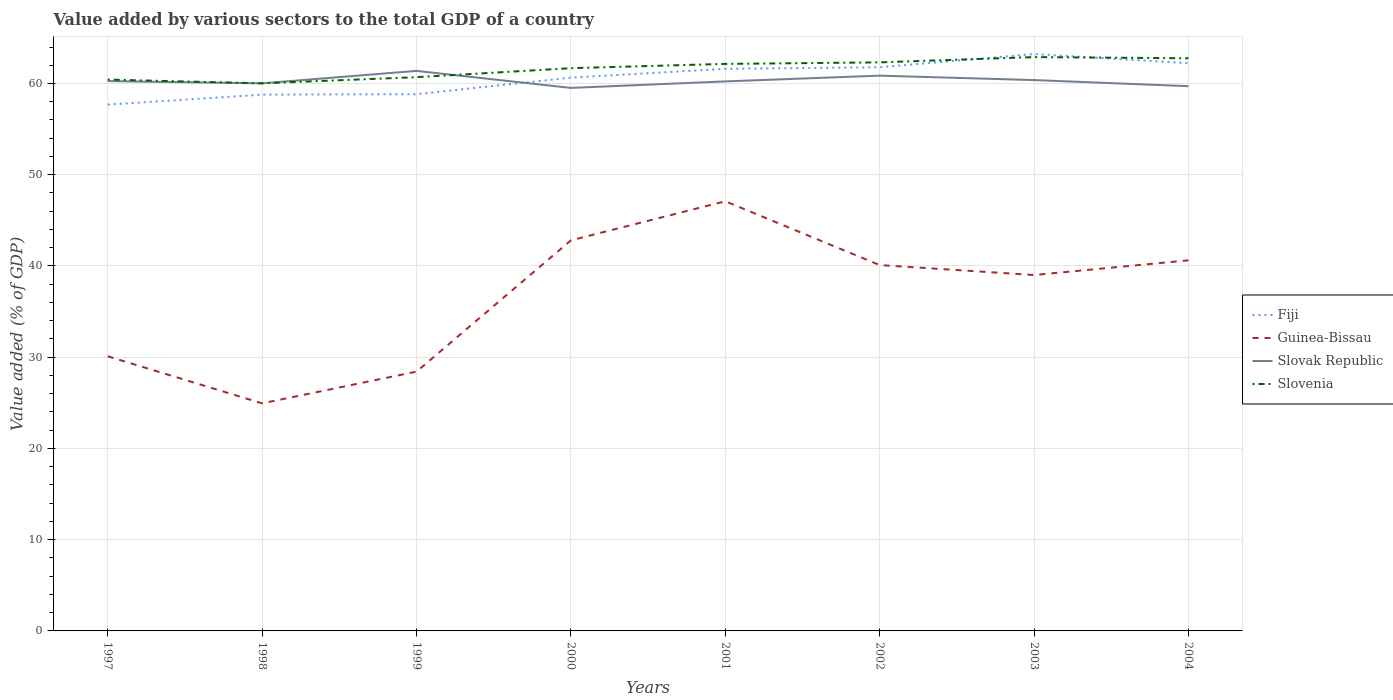Does the line corresponding to Guinea-Bissau intersect with the line corresponding to Slovenia?
Your answer should be very brief. No. Is the number of lines equal to the number of legend labels?
Offer a very short reply. Yes. Across all years, what is the maximum value added by various sectors to the total GDP in Guinea-Bissau?
Provide a succinct answer. 24.94. What is the total value added by various sectors to the total GDP in Fiji in the graph?
Give a very brief answer. -1.86. What is the difference between the highest and the second highest value added by various sectors to the total GDP in Slovak Republic?
Your answer should be very brief. 1.87. How many lines are there?
Your answer should be very brief. 4. How many years are there in the graph?
Keep it short and to the point. 8. Does the graph contain any zero values?
Provide a short and direct response. No. Does the graph contain grids?
Your answer should be compact. Yes. How many legend labels are there?
Give a very brief answer. 4. What is the title of the graph?
Your answer should be very brief. Value added by various sectors to the total GDP of a country. What is the label or title of the Y-axis?
Your answer should be very brief. Value added (% of GDP). What is the Value added (% of GDP) of Fiji in 1997?
Provide a succinct answer. 57.69. What is the Value added (% of GDP) of Guinea-Bissau in 1997?
Offer a terse response. 30.1. What is the Value added (% of GDP) of Slovak Republic in 1997?
Make the answer very short. 60.26. What is the Value added (% of GDP) of Slovenia in 1997?
Give a very brief answer. 60.43. What is the Value added (% of GDP) in Fiji in 1998?
Offer a terse response. 58.78. What is the Value added (% of GDP) in Guinea-Bissau in 1998?
Provide a succinct answer. 24.94. What is the Value added (% of GDP) of Slovak Republic in 1998?
Ensure brevity in your answer.  60.02. What is the Value added (% of GDP) of Slovenia in 1998?
Make the answer very short. 60.02. What is the Value added (% of GDP) of Fiji in 1999?
Offer a terse response. 58.83. What is the Value added (% of GDP) in Guinea-Bissau in 1999?
Offer a very short reply. 28.42. What is the Value added (% of GDP) of Slovak Republic in 1999?
Keep it short and to the point. 61.38. What is the Value added (% of GDP) of Slovenia in 1999?
Offer a very short reply. 60.69. What is the Value added (% of GDP) of Fiji in 2000?
Ensure brevity in your answer.  60.64. What is the Value added (% of GDP) of Guinea-Bissau in 2000?
Provide a succinct answer. 42.81. What is the Value added (% of GDP) in Slovak Republic in 2000?
Your answer should be very brief. 59.52. What is the Value added (% of GDP) in Slovenia in 2000?
Ensure brevity in your answer.  61.68. What is the Value added (% of GDP) of Fiji in 2001?
Your response must be concise. 61.61. What is the Value added (% of GDP) of Guinea-Bissau in 2001?
Provide a short and direct response. 47.09. What is the Value added (% of GDP) of Slovak Republic in 2001?
Offer a terse response. 60.23. What is the Value added (% of GDP) of Slovenia in 2001?
Offer a terse response. 62.15. What is the Value added (% of GDP) in Fiji in 2002?
Your response must be concise. 61.78. What is the Value added (% of GDP) in Guinea-Bissau in 2002?
Your response must be concise. 40.1. What is the Value added (% of GDP) of Slovak Republic in 2002?
Provide a succinct answer. 60.86. What is the Value added (% of GDP) in Slovenia in 2002?
Offer a terse response. 62.32. What is the Value added (% of GDP) in Fiji in 2003?
Your answer should be compact. 63.23. What is the Value added (% of GDP) of Guinea-Bissau in 2003?
Give a very brief answer. 39.01. What is the Value added (% of GDP) in Slovak Republic in 2003?
Your response must be concise. 60.37. What is the Value added (% of GDP) in Slovenia in 2003?
Your answer should be compact. 62.9. What is the Value added (% of GDP) of Fiji in 2004?
Offer a very short reply. 62.23. What is the Value added (% of GDP) in Guinea-Bissau in 2004?
Provide a succinct answer. 40.62. What is the Value added (% of GDP) of Slovak Republic in 2004?
Keep it short and to the point. 59.71. What is the Value added (% of GDP) in Slovenia in 2004?
Your answer should be very brief. 62.76. Across all years, what is the maximum Value added (% of GDP) of Fiji?
Your answer should be very brief. 63.23. Across all years, what is the maximum Value added (% of GDP) of Guinea-Bissau?
Your answer should be compact. 47.09. Across all years, what is the maximum Value added (% of GDP) of Slovak Republic?
Your response must be concise. 61.38. Across all years, what is the maximum Value added (% of GDP) in Slovenia?
Your answer should be very brief. 62.9. Across all years, what is the minimum Value added (% of GDP) of Fiji?
Your response must be concise. 57.69. Across all years, what is the minimum Value added (% of GDP) of Guinea-Bissau?
Keep it short and to the point. 24.94. Across all years, what is the minimum Value added (% of GDP) of Slovak Republic?
Give a very brief answer. 59.52. Across all years, what is the minimum Value added (% of GDP) in Slovenia?
Make the answer very short. 60.02. What is the total Value added (% of GDP) in Fiji in the graph?
Make the answer very short. 484.78. What is the total Value added (% of GDP) in Guinea-Bissau in the graph?
Give a very brief answer. 293.09. What is the total Value added (% of GDP) of Slovak Republic in the graph?
Offer a very short reply. 482.35. What is the total Value added (% of GDP) in Slovenia in the graph?
Make the answer very short. 492.94. What is the difference between the Value added (% of GDP) of Fiji in 1997 and that in 1998?
Offer a very short reply. -1.09. What is the difference between the Value added (% of GDP) in Guinea-Bissau in 1997 and that in 1998?
Offer a very short reply. 5.16. What is the difference between the Value added (% of GDP) in Slovak Republic in 1997 and that in 1998?
Make the answer very short. 0.25. What is the difference between the Value added (% of GDP) in Slovenia in 1997 and that in 1998?
Make the answer very short. 0.41. What is the difference between the Value added (% of GDP) of Fiji in 1997 and that in 1999?
Your response must be concise. -1.14. What is the difference between the Value added (% of GDP) of Guinea-Bissau in 1997 and that in 1999?
Your answer should be very brief. 1.68. What is the difference between the Value added (% of GDP) in Slovak Republic in 1997 and that in 1999?
Give a very brief answer. -1.12. What is the difference between the Value added (% of GDP) of Slovenia in 1997 and that in 1999?
Keep it short and to the point. -0.26. What is the difference between the Value added (% of GDP) of Fiji in 1997 and that in 2000?
Keep it short and to the point. -2.95. What is the difference between the Value added (% of GDP) in Guinea-Bissau in 1997 and that in 2000?
Provide a short and direct response. -12.71. What is the difference between the Value added (% of GDP) in Slovak Republic in 1997 and that in 2000?
Provide a short and direct response. 0.75. What is the difference between the Value added (% of GDP) of Slovenia in 1997 and that in 2000?
Give a very brief answer. -1.25. What is the difference between the Value added (% of GDP) in Fiji in 1997 and that in 2001?
Keep it short and to the point. -3.92. What is the difference between the Value added (% of GDP) of Guinea-Bissau in 1997 and that in 2001?
Your answer should be compact. -16.99. What is the difference between the Value added (% of GDP) of Slovak Republic in 1997 and that in 2001?
Make the answer very short. 0.03. What is the difference between the Value added (% of GDP) of Slovenia in 1997 and that in 2001?
Offer a very short reply. -1.72. What is the difference between the Value added (% of GDP) in Fiji in 1997 and that in 2002?
Ensure brevity in your answer.  -4.09. What is the difference between the Value added (% of GDP) in Guinea-Bissau in 1997 and that in 2002?
Provide a succinct answer. -10. What is the difference between the Value added (% of GDP) in Slovak Republic in 1997 and that in 2002?
Offer a very short reply. -0.6. What is the difference between the Value added (% of GDP) in Slovenia in 1997 and that in 2002?
Make the answer very short. -1.89. What is the difference between the Value added (% of GDP) in Fiji in 1997 and that in 2003?
Ensure brevity in your answer.  -5.54. What is the difference between the Value added (% of GDP) of Guinea-Bissau in 1997 and that in 2003?
Make the answer very short. -8.91. What is the difference between the Value added (% of GDP) in Slovak Republic in 1997 and that in 2003?
Ensure brevity in your answer.  -0.11. What is the difference between the Value added (% of GDP) in Slovenia in 1997 and that in 2003?
Make the answer very short. -2.47. What is the difference between the Value added (% of GDP) of Fiji in 1997 and that in 2004?
Your answer should be compact. -4.54. What is the difference between the Value added (% of GDP) of Guinea-Bissau in 1997 and that in 2004?
Your answer should be very brief. -10.52. What is the difference between the Value added (% of GDP) of Slovak Republic in 1997 and that in 2004?
Ensure brevity in your answer.  0.56. What is the difference between the Value added (% of GDP) in Slovenia in 1997 and that in 2004?
Your answer should be very brief. -2.34. What is the difference between the Value added (% of GDP) in Fiji in 1998 and that in 1999?
Offer a very short reply. -0.05. What is the difference between the Value added (% of GDP) of Guinea-Bissau in 1998 and that in 1999?
Offer a very short reply. -3.48. What is the difference between the Value added (% of GDP) of Slovak Republic in 1998 and that in 1999?
Your answer should be very brief. -1.36. What is the difference between the Value added (% of GDP) in Slovenia in 1998 and that in 1999?
Offer a very short reply. -0.68. What is the difference between the Value added (% of GDP) of Fiji in 1998 and that in 2000?
Give a very brief answer. -1.86. What is the difference between the Value added (% of GDP) in Guinea-Bissau in 1998 and that in 2000?
Offer a terse response. -17.87. What is the difference between the Value added (% of GDP) in Slovak Republic in 1998 and that in 2000?
Provide a succinct answer. 0.5. What is the difference between the Value added (% of GDP) in Slovenia in 1998 and that in 2000?
Offer a very short reply. -1.66. What is the difference between the Value added (% of GDP) in Fiji in 1998 and that in 2001?
Your response must be concise. -2.83. What is the difference between the Value added (% of GDP) in Guinea-Bissau in 1998 and that in 2001?
Offer a terse response. -22.15. What is the difference between the Value added (% of GDP) in Slovak Republic in 1998 and that in 2001?
Make the answer very short. -0.21. What is the difference between the Value added (% of GDP) in Slovenia in 1998 and that in 2001?
Ensure brevity in your answer.  -2.13. What is the difference between the Value added (% of GDP) in Fiji in 1998 and that in 2002?
Provide a succinct answer. -3. What is the difference between the Value added (% of GDP) in Guinea-Bissau in 1998 and that in 2002?
Ensure brevity in your answer.  -15.16. What is the difference between the Value added (% of GDP) in Slovak Republic in 1998 and that in 2002?
Your answer should be very brief. -0.84. What is the difference between the Value added (% of GDP) of Slovenia in 1998 and that in 2002?
Keep it short and to the point. -2.3. What is the difference between the Value added (% of GDP) in Fiji in 1998 and that in 2003?
Your answer should be compact. -4.45. What is the difference between the Value added (% of GDP) of Guinea-Bissau in 1998 and that in 2003?
Offer a very short reply. -14.07. What is the difference between the Value added (% of GDP) of Slovak Republic in 1998 and that in 2003?
Your answer should be very brief. -0.36. What is the difference between the Value added (% of GDP) in Slovenia in 1998 and that in 2003?
Provide a short and direct response. -2.88. What is the difference between the Value added (% of GDP) of Fiji in 1998 and that in 2004?
Your response must be concise. -3.45. What is the difference between the Value added (% of GDP) of Guinea-Bissau in 1998 and that in 2004?
Your response must be concise. -15.68. What is the difference between the Value added (% of GDP) in Slovak Republic in 1998 and that in 2004?
Keep it short and to the point. 0.31. What is the difference between the Value added (% of GDP) in Slovenia in 1998 and that in 2004?
Your answer should be very brief. -2.75. What is the difference between the Value added (% of GDP) in Fiji in 1999 and that in 2000?
Offer a terse response. -1.81. What is the difference between the Value added (% of GDP) in Guinea-Bissau in 1999 and that in 2000?
Provide a short and direct response. -14.39. What is the difference between the Value added (% of GDP) in Slovak Republic in 1999 and that in 2000?
Keep it short and to the point. 1.87. What is the difference between the Value added (% of GDP) in Slovenia in 1999 and that in 2000?
Your answer should be very brief. -0.99. What is the difference between the Value added (% of GDP) of Fiji in 1999 and that in 2001?
Offer a very short reply. -2.78. What is the difference between the Value added (% of GDP) of Guinea-Bissau in 1999 and that in 2001?
Your response must be concise. -18.67. What is the difference between the Value added (% of GDP) in Slovak Republic in 1999 and that in 2001?
Provide a succinct answer. 1.15. What is the difference between the Value added (% of GDP) in Slovenia in 1999 and that in 2001?
Keep it short and to the point. -1.45. What is the difference between the Value added (% of GDP) of Fiji in 1999 and that in 2002?
Provide a short and direct response. -2.95. What is the difference between the Value added (% of GDP) of Guinea-Bissau in 1999 and that in 2002?
Give a very brief answer. -11.68. What is the difference between the Value added (% of GDP) of Slovak Republic in 1999 and that in 2002?
Provide a succinct answer. 0.52. What is the difference between the Value added (% of GDP) of Slovenia in 1999 and that in 2002?
Offer a terse response. -1.62. What is the difference between the Value added (% of GDP) of Fiji in 1999 and that in 2003?
Make the answer very short. -4.4. What is the difference between the Value added (% of GDP) of Guinea-Bissau in 1999 and that in 2003?
Your answer should be very brief. -10.59. What is the difference between the Value added (% of GDP) in Slovenia in 1999 and that in 2003?
Your answer should be compact. -2.2. What is the difference between the Value added (% of GDP) of Fiji in 1999 and that in 2004?
Keep it short and to the point. -3.4. What is the difference between the Value added (% of GDP) in Guinea-Bissau in 1999 and that in 2004?
Your answer should be compact. -12.2. What is the difference between the Value added (% of GDP) in Slovak Republic in 1999 and that in 2004?
Your answer should be compact. 1.68. What is the difference between the Value added (% of GDP) in Slovenia in 1999 and that in 2004?
Keep it short and to the point. -2.07. What is the difference between the Value added (% of GDP) of Fiji in 2000 and that in 2001?
Provide a succinct answer. -0.97. What is the difference between the Value added (% of GDP) of Guinea-Bissau in 2000 and that in 2001?
Offer a terse response. -4.28. What is the difference between the Value added (% of GDP) of Slovak Republic in 2000 and that in 2001?
Your answer should be compact. -0.71. What is the difference between the Value added (% of GDP) of Slovenia in 2000 and that in 2001?
Your answer should be compact. -0.47. What is the difference between the Value added (% of GDP) of Fiji in 2000 and that in 2002?
Your response must be concise. -1.14. What is the difference between the Value added (% of GDP) in Guinea-Bissau in 2000 and that in 2002?
Your response must be concise. 2.71. What is the difference between the Value added (% of GDP) in Slovak Republic in 2000 and that in 2002?
Provide a succinct answer. -1.34. What is the difference between the Value added (% of GDP) in Slovenia in 2000 and that in 2002?
Your answer should be very brief. -0.64. What is the difference between the Value added (% of GDP) in Fiji in 2000 and that in 2003?
Offer a very short reply. -2.59. What is the difference between the Value added (% of GDP) of Guinea-Bissau in 2000 and that in 2003?
Ensure brevity in your answer.  3.8. What is the difference between the Value added (% of GDP) in Slovak Republic in 2000 and that in 2003?
Your answer should be very brief. -0.86. What is the difference between the Value added (% of GDP) in Slovenia in 2000 and that in 2003?
Make the answer very short. -1.22. What is the difference between the Value added (% of GDP) of Fiji in 2000 and that in 2004?
Keep it short and to the point. -1.58. What is the difference between the Value added (% of GDP) in Guinea-Bissau in 2000 and that in 2004?
Offer a very short reply. 2.19. What is the difference between the Value added (% of GDP) of Slovak Republic in 2000 and that in 2004?
Make the answer very short. -0.19. What is the difference between the Value added (% of GDP) of Slovenia in 2000 and that in 2004?
Your answer should be very brief. -1.09. What is the difference between the Value added (% of GDP) in Fiji in 2001 and that in 2002?
Your answer should be compact. -0.18. What is the difference between the Value added (% of GDP) in Guinea-Bissau in 2001 and that in 2002?
Ensure brevity in your answer.  6.99. What is the difference between the Value added (% of GDP) in Slovak Republic in 2001 and that in 2002?
Keep it short and to the point. -0.63. What is the difference between the Value added (% of GDP) in Slovenia in 2001 and that in 2002?
Give a very brief answer. -0.17. What is the difference between the Value added (% of GDP) in Fiji in 2001 and that in 2003?
Provide a succinct answer. -1.62. What is the difference between the Value added (% of GDP) of Guinea-Bissau in 2001 and that in 2003?
Provide a succinct answer. 8.08. What is the difference between the Value added (% of GDP) in Slovak Republic in 2001 and that in 2003?
Make the answer very short. -0.14. What is the difference between the Value added (% of GDP) in Slovenia in 2001 and that in 2003?
Ensure brevity in your answer.  -0.75. What is the difference between the Value added (% of GDP) of Fiji in 2001 and that in 2004?
Provide a succinct answer. -0.62. What is the difference between the Value added (% of GDP) of Guinea-Bissau in 2001 and that in 2004?
Keep it short and to the point. 6.47. What is the difference between the Value added (% of GDP) of Slovak Republic in 2001 and that in 2004?
Keep it short and to the point. 0.52. What is the difference between the Value added (% of GDP) in Slovenia in 2001 and that in 2004?
Your response must be concise. -0.62. What is the difference between the Value added (% of GDP) in Fiji in 2002 and that in 2003?
Your answer should be very brief. -1.45. What is the difference between the Value added (% of GDP) of Guinea-Bissau in 2002 and that in 2003?
Offer a terse response. 1.09. What is the difference between the Value added (% of GDP) of Slovak Republic in 2002 and that in 2003?
Ensure brevity in your answer.  0.49. What is the difference between the Value added (% of GDP) of Slovenia in 2002 and that in 2003?
Your answer should be compact. -0.58. What is the difference between the Value added (% of GDP) in Fiji in 2002 and that in 2004?
Your answer should be very brief. -0.44. What is the difference between the Value added (% of GDP) of Guinea-Bissau in 2002 and that in 2004?
Give a very brief answer. -0.52. What is the difference between the Value added (% of GDP) in Slovak Republic in 2002 and that in 2004?
Your answer should be compact. 1.15. What is the difference between the Value added (% of GDP) of Slovenia in 2002 and that in 2004?
Offer a terse response. -0.45. What is the difference between the Value added (% of GDP) in Guinea-Bissau in 2003 and that in 2004?
Your response must be concise. -1.61. What is the difference between the Value added (% of GDP) in Slovak Republic in 2003 and that in 2004?
Provide a succinct answer. 0.67. What is the difference between the Value added (% of GDP) of Slovenia in 2003 and that in 2004?
Your answer should be very brief. 0.13. What is the difference between the Value added (% of GDP) of Fiji in 1997 and the Value added (% of GDP) of Guinea-Bissau in 1998?
Your response must be concise. 32.75. What is the difference between the Value added (% of GDP) of Fiji in 1997 and the Value added (% of GDP) of Slovak Republic in 1998?
Provide a short and direct response. -2.33. What is the difference between the Value added (% of GDP) in Fiji in 1997 and the Value added (% of GDP) in Slovenia in 1998?
Give a very brief answer. -2.33. What is the difference between the Value added (% of GDP) in Guinea-Bissau in 1997 and the Value added (% of GDP) in Slovak Republic in 1998?
Provide a short and direct response. -29.92. What is the difference between the Value added (% of GDP) of Guinea-Bissau in 1997 and the Value added (% of GDP) of Slovenia in 1998?
Offer a terse response. -29.92. What is the difference between the Value added (% of GDP) of Slovak Republic in 1997 and the Value added (% of GDP) of Slovenia in 1998?
Provide a short and direct response. 0.25. What is the difference between the Value added (% of GDP) of Fiji in 1997 and the Value added (% of GDP) of Guinea-Bissau in 1999?
Ensure brevity in your answer.  29.27. What is the difference between the Value added (% of GDP) in Fiji in 1997 and the Value added (% of GDP) in Slovak Republic in 1999?
Provide a short and direct response. -3.69. What is the difference between the Value added (% of GDP) in Fiji in 1997 and the Value added (% of GDP) in Slovenia in 1999?
Provide a succinct answer. -3.01. What is the difference between the Value added (% of GDP) of Guinea-Bissau in 1997 and the Value added (% of GDP) of Slovak Republic in 1999?
Provide a short and direct response. -31.28. What is the difference between the Value added (% of GDP) in Guinea-Bissau in 1997 and the Value added (% of GDP) in Slovenia in 1999?
Make the answer very short. -30.59. What is the difference between the Value added (% of GDP) in Slovak Republic in 1997 and the Value added (% of GDP) in Slovenia in 1999?
Make the answer very short. -0.43. What is the difference between the Value added (% of GDP) of Fiji in 1997 and the Value added (% of GDP) of Guinea-Bissau in 2000?
Keep it short and to the point. 14.88. What is the difference between the Value added (% of GDP) of Fiji in 1997 and the Value added (% of GDP) of Slovak Republic in 2000?
Provide a short and direct response. -1.83. What is the difference between the Value added (% of GDP) of Fiji in 1997 and the Value added (% of GDP) of Slovenia in 2000?
Offer a terse response. -3.99. What is the difference between the Value added (% of GDP) of Guinea-Bissau in 1997 and the Value added (% of GDP) of Slovak Republic in 2000?
Ensure brevity in your answer.  -29.42. What is the difference between the Value added (% of GDP) in Guinea-Bissau in 1997 and the Value added (% of GDP) in Slovenia in 2000?
Provide a succinct answer. -31.58. What is the difference between the Value added (% of GDP) of Slovak Republic in 1997 and the Value added (% of GDP) of Slovenia in 2000?
Offer a terse response. -1.42. What is the difference between the Value added (% of GDP) of Fiji in 1997 and the Value added (% of GDP) of Guinea-Bissau in 2001?
Give a very brief answer. 10.6. What is the difference between the Value added (% of GDP) in Fiji in 1997 and the Value added (% of GDP) in Slovak Republic in 2001?
Keep it short and to the point. -2.54. What is the difference between the Value added (% of GDP) of Fiji in 1997 and the Value added (% of GDP) of Slovenia in 2001?
Offer a terse response. -4.46. What is the difference between the Value added (% of GDP) of Guinea-Bissau in 1997 and the Value added (% of GDP) of Slovak Republic in 2001?
Your response must be concise. -30.13. What is the difference between the Value added (% of GDP) in Guinea-Bissau in 1997 and the Value added (% of GDP) in Slovenia in 2001?
Provide a succinct answer. -32.05. What is the difference between the Value added (% of GDP) in Slovak Republic in 1997 and the Value added (% of GDP) in Slovenia in 2001?
Offer a terse response. -1.88. What is the difference between the Value added (% of GDP) in Fiji in 1997 and the Value added (% of GDP) in Guinea-Bissau in 2002?
Provide a short and direct response. 17.59. What is the difference between the Value added (% of GDP) in Fiji in 1997 and the Value added (% of GDP) in Slovak Republic in 2002?
Provide a succinct answer. -3.17. What is the difference between the Value added (% of GDP) in Fiji in 1997 and the Value added (% of GDP) in Slovenia in 2002?
Offer a very short reply. -4.63. What is the difference between the Value added (% of GDP) of Guinea-Bissau in 1997 and the Value added (% of GDP) of Slovak Republic in 2002?
Your answer should be very brief. -30.76. What is the difference between the Value added (% of GDP) in Guinea-Bissau in 1997 and the Value added (% of GDP) in Slovenia in 2002?
Your answer should be compact. -32.22. What is the difference between the Value added (% of GDP) in Slovak Republic in 1997 and the Value added (% of GDP) in Slovenia in 2002?
Your answer should be compact. -2.05. What is the difference between the Value added (% of GDP) in Fiji in 1997 and the Value added (% of GDP) in Guinea-Bissau in 2003?
Offer a terse response. 18.68. What is the difference between the Value added (% of GDP) of Fiji in 1997 and the Value added (% of GDP) of Slovak Republic in 2003?
Ensure brevity in your answer.  -2.69. What is the difference between the Value added (% of GDP) in Fiji in 1997 and the Value added (% of GDP) in Slovenia in 2003?
Offer a terse response. -5.21. What is the difference between the Value added (% of GDP) of Guinea-Bissau in 1997 and the Value added (% of GDP) of Slovak Republic in 2003?
Provide a short and direct response. -30.28. What is the difference between the Value added (% of GDP) in Guinea-Bissau in 1997 and the Value added (% of GDP) in Slovenia in 2003?
Keep it short and to the point. -32.8. What is the difference between the Value added (% of GDP) of Slovak Republic in 1997 and the Value added (% of GDP) of Slovenia in 2003?
Your response must be concise. -2.63. What is the difference between the Value added (% of GDP) of Fiji in 1997 and the Value added (% of GDP) of Guinea-Bissau in 2004?
Your response must be concise. 17.07. What is the difference between the Value added (% of GDP) of Fiji in 1997 and the Value added (% of GDP) of Slovak Republic in 2004?
Keep it short and to the point. -2.02. What is the difference between the Value added (% of GDP) in Fiji in 1997 and the Value added (% of GDP) in Slovenia in 2004?
Keep it short and to the point. -5.08. What is the difference between the Value added (% of GDP) of Guinea-Bissau in 1997 and the Value added (% of GDP) of Slovak Republic in 2004?
Provide a short and direct response. -29.61. What is the difference between the Value added (% of GDP) of Guinea-Bissau in 1997 and the Value added (% of GDP) of Slovenia in 2004?
Offer a very short reply. -32.67. What is the difference between the Value added (% of GDP) in Slovak Republic in 1997 and the Value added (% of GDP) in Slovenia in 2004?
Your answer should be very brief. -2.5. What is the difference between the Value added (% of GDP) in Fiji in 1998 and the Value added (% of GDP) in Guinea-Bissau in 1999?
Provide a short and direct response. 30.36. What is the difference between the Value added (% of GDP) of Fiji in 1998 and the Value added (% of GDP) of Slovak Republic in 1999?
Your answer should be compact. -2.6. What is the difference between the Value added (% of GDP) of Fiji in 1998 and the Value added (% of GDP) of Slovenia in 1999?
Provide a short and direct response. -1.91. What is the difference between the Value added (% of GDP) of Guinea-Bissau in 1998 and the Value added (% of GDP) of Slovak Republic in 1999?
Provide a short and direct response. -36.44. What is the difference between the Value added (% of GDP) in Guinea-Bissau in 1998 and the Value added (% of GDP) in Slovenia in 1999?
Make the answer very short. -35.75. What is the difference between the Value added (% of GDP) of Slovak Republic in 1998 and the Value added (% of GDP) of Slovenia in 1999?
Offer a very short reply. -0.68. What is the difference between the Value added (% of GDP) in Fiji in 1998 and the Value added (% of GDP) in Guinea-Bissau in 2000?
Your answer should be very brief. 15.97. What is the difference between the Value added (% of GDP) of Fiji in 1998 and the Value added (% of GDP) of Slovak Republic in 2000?
Give a very brief answer. -0.74. What is the difference between the Value added (% of GDP) in Fiji in 1998 and the Value added (% of GDP) in Slovenia in 2000?
Your response must be concise. -2.9. What is the difference between the Value added (% of GDP) in Guinea-Bissau in 1998 and the Value added (% of GDP) in Slovak Republic in 2000?
Provide a succinct answer. -34.57. What is the difference between the Value added (% of GDP) in Guinea-Bissau in 1998 and the Value added (% of GDP) in Slovenia in 2000?
Offer a very short reply. -36.74. What is the difference between the Value added (% of GDP) of Slovak Republic in 1998 and the Value added (% of GDP) of Slovenia in 2000?
Offer a terse response. -1.66. What is the difference between the Value added (% of GDP) in Fiji in 1998 and the Value added (% of GDP) in Guinea-Bissau in 2001?
Offer a very short reply. 11.69. What is the difference between the Value added (% of GDP) in Fiji in 1998 and the Value added (% of GDP) in Slovak Republic in 2001?
Your answer should be very brief. -1.45. What is the difference between the Value added (% of GDP) in Fiji in 1998 and the Value added (% of GDP) in Slovenia in 2001?
Keep it short and to the point. -3.37. What is the difference between the Value added (% of GDP) of Guinea-Bissau in 1998 and the Value added (% of GDP) of Slovak Republic in 2001?
Make the answer very short. -35.29. What is the difference between the Value added (% of GDP) of Guinea-Bissau in 1998 and the Value added (% of GDP) of Slovenia in 2001?
Provide a succinct answer. -37.21. What is the difference between the Value added (% of GDP) of Slovak Republic in 1998 and the Value added (% of GDP) of Slovenia in 2001?
Offer a terse response. -2.13. What is the difference between the Value added (% of GDP) in Fiji in 1998 and the Value added (% of GDP) in Guinea-Bissau in 2002?
Provide a succinct answer. 18.68. What is the difference between the Value added (% of GDP) of Fiji in 1998 and the Value added (% of GDP) of Slovak Republic in 2002?
Ensure brevity in your answer.  -2.08. What is the difference between the Value added (% of GDP) of Fiji in 1998 and the Value added (% of GDP) of Slovenia in 2002?
Offer a very short reply. -3.54. What is the difference between the Value added (% of GDP) of Guinea-Bissau in 1998 and the Value added (% of GDP) of Slovak Republic in 2002?
Offer a terse response. -35.92. What is the difference between the Value added (% of GDP) of Guinea-Bissau in 1998 and the Value added (% of GDP) of Slovenia in 2002?
Offer a very short reply. -37.37. What is the difference between the Value added (% of GDP) of Slovak Republic in 1998 and the Value added (% of GDP) of Slovenia in 2002?
Ensure brevity in your answer.  -2.3. What is the difference between the Value added (% of GDP) of Fiji in 1998 and the Value added (% of GDP) of Guinea-Bissau in 2003?
Your answer should be compact. 19.77. What is the difference between the Value added (% of GDP) in Fiji in 1998 and the Value added (% of GDP) in Slovak Republic in 2003?
Your answer should be compact. -1.6. What is the difference between the Value added (% of GDP) in Fiji in 1998 and the Value added (% of GDP) in Slovenia in 2003?
Ensure brevity in your answer.  -4.12. What is the difference between the Value added (% of GDP) in Guinea-Bissau in 1998 and the Value added (% of GDP) in Slovak Republic in 2003?
Offer a very short reply. -35.43. What is the difference between the Value added (% of GDP) of Guinea-Bissau in 1998 and the Value added (% of GDP) of Slovenia in 2003?
Offer a terse response. -37.95. What is the difference between the Value added (% of GDP) of Slovak Republic in 1998 and the Value added (% of GDP) of Slovenia in 2003?
Give a very brief answer. -2.88. What is the difference between the Value added (% of GDP) in Fiji in 1998 and the Value added (% of GDP) in Guinea-Bissau in 2004?
Your answer should be very brief. 18.16. What is the difference between the Value added (% of GDP) of Fiji in 1998 and the Value added (% of GDP) of Slovak Republic in 2004?
Provide a short and direct response. -0.93. What is the difference between the Value added (% of GDP) in Fiji in 1998 and the Value added (% of GDP) in Slovenia in 2004?
Your response must be concise. -3.99. What is the difference between the Value added (% of GDP) in Guinea-Bissau in 1998 and the Value added (% of GDP) in Slovak Republic in 2004?
Your answer should be very brief. -34.76. What is the difference between the Value added (% of GDP) of Guinea-Bissau in 1998 and the Value added (% of GDP) of Slovenia in 2004?
Keep it short and to the point. -37.82. What is the difference between the Value added (% of GDP) of Slovak Republic in 1998 and the Value added (% of GDP) of Slovenia in 2004?
Your response must be concise. -2.75. What is the difference between the Value added (% of GDP) in Fiji in 1999 and the Value added (% of GDP) in Guinea-Bissau in 2000?
Provide a succinct answer. 16.02. What is the difference between the Value added (% of GDP) of Fiji in 1999 and the Value added (% of GDP) of Slovak Republic in 2000?
Provide a succinct answer. -0.69. What is the difference between the Value added (% of GDP) in Fiji in 1999 and the Value added (% of GDP) in Slovenia in 2000?
Provide a short and direct response. -2.85. What is the difference between the Value added (% of GDP) of Guinea-Bissau in 1999 and the Value added (% of GDP) of Slovak Republic in 2000?
Keep it short and to the point. -31.1. What is the difference between the Value added (% of GDP) in Guinea-Bissau in 1999 and the Value added (% of GDP) in Slovenia in 2000?
Your answer should be compact. -33.26. What is the difference between the Value added (% of GDP) in Slovak Republic in 1999 and the Value added (% of GDP) in Slovenia in 2000?
Your answer should be very brief. -0.3. What is the difference between the Value added (% of GDP) of Fiji in 1999 and the Value added (% of GDP) of Guinea-Bissau in 2001?
Provide a short and direct response. 11.74. What is the difference between the Value added (% of GDP) in Fiji in 1999 and the Value added (% of GDP) in Slovak Republic in 2001?
Your response must be concise. -1.4. What is the difference between the Value added (% of GDP) in Fiji in 1999 and the Value added (% of GDP) in Slovenia in 2001?
Offer a terse response. -3.32. What is the difference between the Value added (% of GDP) of Guinea-Bissau in 1999 and the Value added (% of GDP) of Slovak Republic in 2001?
Make the answer very short. -31.81. What is the difference between the Value added (% of GDP) in Guinea-Bissau in 1999 and the Value added (% of GDP) in Slovenia in 2001?
Offer a very short reply. -33.73. What is the difference between the Value added (% of GDP) in Slovak Republic in 1999 and the Value added (% of GDP) in Slovenia in 2001?
Your response must be concise. -0.77. What is the difference between the Value added (% of GDP) in Fiji in 1999 and the Value added (% of GDP) in Guinea-Bissau in 2002?
Provide a succinct answer. 18.73. What is the difference between the Value added (% of GDP) in Fiji in 1999 and the Value added (% of GDP) in Slovak Republic in 2002?
Your answer should be compact. -2.03. What is the difference between the Value added (% of GDP) in Fiji in 1999 and the Value added (% of GDP) in Slovenia in 2002?
Provide a succinct answer. -3.49. What is the difference between the Value added (% of GDP) of Guinea-Bissau in 1999 and the Value added (% of GDP) of Slovak Republic in 2002?
Your answer should be compact. -32.44. What is the difference between the Value added (% of GDP) in Guinea-Bissau in 1999 and the Value added (% of GDP) in Slovenia in 2002?
Ensure brevity in your answer.  -33.9. What is the difference between the Value added (% of GDP) in Slovak Republic in 1999 and the Value added (% of GDP) in Slovenia in 2002?
Offer a terse response. -0.93. What is the difference between the Value added (% of GDP) in Fiji in 1999 and the Value added (% of GDP) in Guinea-Bissau in 2003?
Provide a short and direct response. 19.82. What is the difference between the Value added (% of GDP) in Fiji in 1999 and the Value added (% of GDP) in Slovak Republic in 2003?
Ensure brevity in your answer.  -1.55. What is the difference between the Value added (% of GDP) of Fiji in 1999 and the Value added (% of GDP) of Slovenia in 2003?
Make the answer very short. -4.07. What is the difference between the Value added (% of GDP) of Guinea-Bissau in 1999 and the Value added (% of GDP) of Slovak Republic in 2003?
Provide a short and direct response. -31.95. What is the difference between the Value added (% of GDP) of Guinea-Bissau in 1999 and the Value added (% of GDP) of Slovenia in 2003?
Give a very brief answer. -34.48. What is the difference between the Value added (% of GDP) in Slovak Republic in 1999 and the Value added (% of GDP) in Slovenia in 2003?
Offer a terse response. -1.51. What is the difference between the Value added (% of GDP) of Fiji in 1999 and the Value added (% of GDP) of Guinea-Bissau in 2004?
Provide a short and direct response. 18.21. What is the difference between the Value added (% of GDP) of Fiji in 1999 and the Value added (% of GDP) of Slovak Republic in 2004?
Your answer should be compact. -0.88. What is the difference between the Value added (% of GDP) in Fiji in 1999 and the Value added (% of GDP) in Slovenia in 2004?
Offer a terse response. -3.94. What is the difference between the Value added (% of GDP) of Guinea-Bissau in 1999 and the Value added (% of GDP) of Slovak Republic in 2004?
Your answer should be compact. -31.29. What is the difference between the Value added (% of GDP) in Guinea-Bissau in 1999 and the Value added (% of GDP) in Slovenia in 2004?
Provide a short and direct response. -34.34. What is the difference between the Value added (% of GDP) of Slovak Republic in 1999 and the Value added (% of GDP) of Slovenia in 2004?
Keep it short and to the point. -1.38. What is the difference between the Value added (% of GDP) in Fiji in 2000 and the Value added (% of GDP) in Guinea-Bissau in 2001?
Give a very brief answer. 13.55. What is the difference between the Value added (% of GDP) in Fiji in 2000 and the Value added (% of GDP) in Slovak Republic in 2001?
Offer a very short reply. 0.41. What is the difference between the Value added (% of GDP) in Fiji in 2000 and the Value added (% of GDP) in Slovenia in 2001?
Offer a very short reply. -1.51. What is the difference between the Value added (% of GDP) of Guinea-Bissau in 2000 and the Value added (% of GDP) of Slovak Republic in 2001?
Offer a very short reply. -17.42. What is the difference between the Value added (% of GDP) of Guinea-Bissau in 2000 and the Value added (% of GDP) of Slovenia in 2001?
Your response must be concise. -19.34. What is the difference between the Value added (% of GDP) in Slovak Republic in 2000 and the Value added (% of GDP) in Slovenia in 2001?
Ensure brevity in your answer.  -2.63. What is the difference between the Value added (% of GDP) in Fiji in 2000 and the Value added (% of GDP) in Guinea-Bissau in 2002?
Give a very brief answer. 20.54. What is the difference between the Value added (% of GDP) in Fiji in 2000 and the Value added (% of GDP) in Slovak Republic in 2002?
Provide a short and direct response. -0.22. What is the difference between the Value added (% of GDP) of Fiji in 2000 and the Value added (% of GDP) of Slovenia in 2002?
Offer a very short reply. -1.67. What is the difference between the Value added (% of GDP) of Guinea-Bissau in 2000 and the Value added (% of GDP) of Slovak Republic in 2002?
Ensure brevity in your answer.  -18.05. What is the difference between the Value added (% of GDP) of Guinea-Bissau in 2000 and the Value added (% of GDP) of Slovenia in 2002?
Your response must be concise. -19.5. What is the difference between the Value added (% of GDP) in Slovak Republic in 2000 and the Value added (% of GDP) in Slovenia in 2002?
Offer a very short reply. -2.8. What is the difference between the Value added (% of GDP) of Fiji in 2000 and the Value added (% of GDP) of Guinea-Bissau in 2003?
Offer a very short reply. 21.63. What is the difference between the Value added (% of GDP) in Fiji in 2000 and the Value added (% of GDP) in Slovak Republic in 2003?
Provide a succinct answer. 0.27. What is the difference between the Value added (% of GDP) of Fiji in 2000 and the Value added (% of GDP) of Slovenia in 2003?
Give a very brief answer. -2.25. What is the difference between the Value added (% of GDP) in Guinea-Bissau in 2000 and the Value added (% of GDP) in Slovak Republic in 2003?
Provide a short and direct response. -17.56. What is the difference between the Value added (% of GDP) in Guinea-Bissau in 2000 and the Value added (% of GDP) in Slovenia in 2003?
Offer a very short reply. -20.08. What is the difference between the Value added (% of GDP) of Slovak Republic in 2000 and the Value added (% of GDP) of Slovenia in 2003?
Your answer should be compact. -3.38. What is the difference between the Value added (% of GDP) of Fiji in 2000 and the Value added (% of GDP) of Guinea-Bissau in 2004?
Keep it short and to the point. 20.02. What is the difference between the Value added (% of GDP) in Fiji in 2000 and the Value added (% of GDP) in Slovak Republic in 2004?
Keep it short and to the point. 0.94. What is the difference between the Value added (% of GDP) in Fiji in 2000 and the Value added (% of GDP) in Slovenia in 2004?
Provide a short and direct response. -2.12. What is the difference between the Value added (% of GDP) of Guinea-Bissau in 2000 and the Value added (% of GDP) of Slovak Republic in 2004?
Keep it short and to the point. -16.89. What is the difference between the Value added (% of GDP) in Guinea-Bissau in 2000 and the Value added (% of GDP) in Slovenia in 2004?
Keep it short and to the point. -19.95. What is the difference between the Value added (% of GDP) of Slovak Republic in 2000 and the Value added (% of GDP) of Slovenia in 2004?
Give a very brief answer. -3.25. What is the difference between the Value added (% of GDP) in Fiji in 2001 and the Value added (% of GDP) in Guinea-Bissau in 2002?
Your response must be concise. 21.51. What is the difference between the Value added (% of GDP) in Fiji in 2001 and the Value added (% of GDP) in Slovak Republic in 2002?
Offer a terse response. 0.75. What is the difference between the Value added (% of GDP) in Fiji in 2001 and the Value added (% of GDP) in Slovenia in 2002?
Your response must be concise. -0.71. What is the difference between the Value added (% of GDP) of Guinea-Bissau in 2001 and the Value added (% of GDP) of Slovak Republic in 2002?
Keep it short and to the point. -13.77. What is the difference between the Value added (% of GDP) in Guinea-Bissau in 2001 and the Value added (% of GDP) in Slovenia in 2002?
Ensure brevity in your answer.  -15.22. What is the difference between the Value added (% of GDP) in Slovak Republic in 2001 and the Value added (% of GDP) in Slovenia in 2002?
Offer a very short reply. -2.09. What is the difference between the Value added (% of GDP) of Fiji in 2001 and the Value added (% of GDP) of Guinea-Bissau in 2003?
Your answer should be very brief. 22.6. What is the difference between the Value added (% of GDP) in Fiji in 2001 and the Value added (% of GDP) in Slovak Republic in 2003?
Give a very brief answer. 1.23. What is the difference between the Value added (% of GDP) in Fiji in 2001 and the Value added (% of GDP) in Slovenia in 2003?
Provide a succinct answer. -1.29. What is the difference between the Value added (% of GDP) in Guinea-Bissau in 2001 and the Value added (% of GDP) in Slovak Republic in 2003?
Offer a very short reply. -13.28. What is the difference between the Value added (% of GDP) of Guinea-Bissau in 2001 and the Value added (% of GDP) of Slovenia in 2003?
Give a very brief answer. -15.8. What is the difference between the Value added (% of GDP) of Slovak Republic in 2001 and the Value added (% of GDP) of Slovenia in 2003?
Provide a succinct answer. -2.67. What is the difference between the Value added (% of GDP) of Fiji in 2001 and the Value added (% of GDP) of Guinea-Bissau in 2004?
Your answer should be very brief. 20.99. What is the difference between the Value added (% of GDP) in Fiji in 2001 and the Value added (% of GDP) in Slovak Republic in 2004?
Give a very brief answer. 1.9. What is the difference between the Value added (% of GDP) in Fiji in 2001 and the Value added (% of GDP) in Slovenia in 2004?
Offer a terse response. -1.16. What is the difference between the Value added (% of GDP) in Guinea-Bissau in 2001 and the Value added (% of GDP) in Slovak Republic in 2004?
Your answer should be very brief. -12.61. What is the difference between the Value added (% of GDP) of Guinea-Bissau in 2001 and the Value added (% of GDP) of Slovenia in 2004?
Your answer should be very brief. -15.67. What is the difference between the Value added (% of GDP) in Slovak Republic in 2001 and the Value added (% of GDP) in Slovenia in 2004?
Give a very brief answer. -2.54. What is the difference between the Value added (% of GDP) of Fiji in 2002 and the Value added (% of GDP) of Guinea-Bissau in 2003?
Provide a short and direct response. 22.77. What is the difference between the Value added (% of GDP) in Fiji in 2002 and the Value added (% of GDP) in Slovak Republic in 2003?
Offer a terse response. 1.41. What is the difference between the Value added (% of GDP) of Fiji in 2002 and the Value added (% of GDP) of Slovenia in 2003?
Provide a short and direct response. -1.11. What is the difference between the Value added (% of GDP) in Guinea-Bissau in 2002 and the Value added (% of GDP) in Slovak Republic in 2003?
Keep it short and to the point. -20.28. What is the difference between the Value added (% of GDP) of Guinea-Bissau in 2002 and the Value added (% of GDP) of Slovenia in 2003?
Your response must be concise. -22.8. What is the difference between the Value added (% of GDP) of Slovak Republic in 2002 and the Value added (% of GDP) of Slovenia in 2003?
Offer a terse response. -2.04. What is the difference between the Value added (% of GDP) of Fiji in 2002 and the Value added (% of GDP) of Guinea-Bissau in 2004?
Your answer should be very brief. 21.16. What is the difference between the Value added (% of GDP) in Fiji in 2002 and the Value added (% of GDP) in Slovak Republic in 2004?
Offer a terse response. 2.08. What is the difference between the Value added (% of GDP) in Fiji in 2002 and the Value added (% of GDP) in Slovenia in 2004?
Keep it short and to the point. -0.98. What is the difference between the Value added (% of GDP) in Guinea-Bissau in 2002 and the Value added (% of GDP) in Slovak Republic in 2004?
Give a very brief answer. -19.61. What is the difference between the Value added (% of GDP) of Guinea-Bissau in 2002 and the Value added (% of GDP) of Slovenia in 2004?
Offer a terse response. -22.67. What is the difference between the Value added (% of GDP) in Slovak Republic in 2002 and the Value added (% of GDP) in Slovenia in 2004?
Give a very brief answer. -1.9. What is the difference between the Value added (% of GDP) of Fiji in 2003 and the Value added (% of GDP) of Guinea-Bissau in 2004?
Your answer should be very brief. 22.61. What is the difference between the Value added (% of GDP) in Fiji in 2003 and the Value added (% of GDP) in Slovak Republic in 2004?
Ensure brevity in your answer.  3.52. What is the difference between the Value added (% of GDP) of Fiji in 2003 and the Value added (% of GDP) of Slovenia in 2004?
Provide a succinct answer. 0.46. What is the difference between the Value added (% of GDP) of Guinea-Bissau in 2003 and the Value added (% of GDP) of Slovak Republic in 2004?
Ensure brevity in your answer.  -20.7. What is the difference between the Value added (% of GDP) in Guinea-Bissau in 2003 and the Value added (% of GDP) in Slovenia in 2004?
Make the answer very short. -23.76. What is the difference between the Value added (% of GDP) of Slovak Republic in 2003 and the Value added (% of GDP) of Slovenia in 2004?
Ensure brevity in your answer.  -2.39. What is the average Value added (% of GDP) in Fiji per year?
Offer a terse response. 60.6. What is the average Value added (% of GDP) of Guinea-Bissau per year?
Provide a short and direct response. 36.64. What is the average Value added (% of GDP) in Slovak Republic per year?
Provide a succinct answer. 60.29. What is the average Value added (% of GDP) of Slovenia per year?
Keep it short and to the point. 61.62. In the year 1997, what is the difference between the Value added (% of GDP) in Fiji and Value added (% of GDP) in Guinea-Bissau?
Provide a short and direct response. 27.59. In the year 1997, what is the difference between the Value added (% of GDP) in Fiji and Value added (% of GDP) in Slovak Republic?
Your response must be concise. -2.58. In the year 1997, what is the difference between the Value added (% of GDP) of Fiji and Value added (% of GDP) of Slovenia?
Offer a very short reply. -2.74. In the year 1997, what is the difference between the Value added (% of GDP) in Guinea-Bissau and Value added (% of GDP) in Slovak Republic?
Your answer should be very brief. -30.17. In the year 1997, what is the difference between the Value added (% of GDP) of Guinea-Bissau and Value added (% of GDP) of Slovenia?
Offer a very short reply. -30.33. In the year 1997, what is the difference between the Value added (% of GDP) in Slovak Republic and Value added (% of GDP) in Slovenia?
Provide a short and direct response. -0.17. In the year 1998, what is the difference between the Value added (% of GDP) of Fiji and Value added (% of GDP) of Guinea-Bissau?
Your answer should be very brief. 33.84. In the year 1998, what is the difference between the Value added (% of GDP) of Fiji and Value added (% of GDP) of Slovak Republic?
Offer a terse response. -1.24. In the year 1998, what is the difference between the Value added (% of GDP) in Fiji and Value added (% of GDP) in Slovenia?
Keep it short and to the point. -1.24. In the year 1998, what is the difference between the Value added (% of GDP) in Guinea-Bissau and Value added (% of GDP) in Slovak Republic?
Your answer should be compact. -35.08. In the year 1998, what is the difference between the Value added (% of GDP) of Guinea-Bissau and Value added (% of GDP) of Slovenia?
Provide a short and direct response. -35.08. In the year 1998, what is the difference between the Value added (% of GDP) in Slovak Republic and Value added (% of GDP) in Slovenia?
Your response must be concise. -0. In the year 1999, what is the difference between the Value added (% of GDP) of Fiji and Value added (% of GDP) of Guinea-Bissau?
Provide a succinct answer. 30.41. In the year 1999, what is the difference between the Value added (% of GDP) of Fiji and Value added (% of GDP) of Slovak Republic?
Provide a short and direct response. -2.55. In the year 1999, what is the difference between the Value added (% of GDP) in Fiji and Value added (% of GDP) in Slovenia?
Provide a succinct answer. -1.87. In the year 1999, what is the difference between the Value added (% of GDP) of Guinea-Bissau and Value added (% of GDP) of Slovak Republic?
Give a very brief answer. -32.96. In the year 1999, what is the difference between the Value added (% of GDP) in Guinea-Bissau and Value added (% of GDP) in Slovenia?
Give a very brief answer. -32.27. In the year 1999, what is the difference between the Value added (% of GDP) in Slovak Republic and Value added (% of GDP) in Slovenia?
Make the answer very short. 0.69. In the year 2000, what is the difference between the Value added (% of GDP) in Fiji and Value added (% of GDP) in Guinea-Bissau?
Provide a short and direct response. 17.83. In the year 2000, what is the difference between the Value added (% of GDP) in Fiji and Value added (% of GDP) in Slovak Republic?
Offer a terse response. 1.13. In the year 2000, what is the difference between the Value added (% of GDP) in Fiji and Value added (% of GDP) in Slovenia?
Give a very brief answer. -1.04. In the year 2000, what is the difference between the Value added (% of GDP) of Guinea-Bissau and Value added (% of GDP) of Slovak Republic?
Provide a succinct answer. -16.71. In the year 2000, what is the difference between the Value added (% of GDP) of Guinea-Bissau and Value added (% of GDP) of Slovenia?
Provide a succinct answer. -18.87. In the year 2000, what is the difference between the Value added (% of GDP) of Slovak Republic and Value added (% of GDP) of Slovenia?
Your response must be concise. -2.16. In the year 2001, what is the difference between the Value added (% of GDP) in Fiji and Value added (% of GDP) in Guinea-Bissau?
Make the answer very short. 14.52. In the year 2001, what is the difference between the Value added (% of GDP) of Fiji and Value added (% of GDP) of Slovak Republic?
Give a very brief answer. 1.38. In the year 2001, what is the difference between the Value added (% of GDP) in Fiji and Value added (% of GDP) in Slovenia?
Offer a very short reply. -0.54. In the year 2001, what is the difference between the Value added (% of GDP) in Guinea-Bissau and Value added (% of GDP) in Slovak Republic?
Make the answer very short. -13.14. In the year 2001, what is the difference between the Value added (% of GDP) of Guinea-Bissau and Value added (% of GDP) of Slovenia?
Provide a short and direct response. -15.06. In the year 2001, what is the difference between the Value added (% of GDP) in Slovak Republic and Value added (% of GDP) in Slovenia?
Give a very brief answer. -1.92. In the year 2002, what is the difference between the Value added (% of GDP) in Fiji and Value added (% of GDP) in Guinea-Bissau?
Offer a very short reply. 21.68. In the year 2002, what is the difference between the Value added (% of GDP) in Fiji and Value added (% of GDP) in Slovak Republic?
Give a very brief answer. 0.92. In the year 2002, what is the difference between the Value added (% of GDP) in Fiji and Value added (% of GDP) in Slovenia?
Your answer should be compact. -0.53. In the year 2002, what is the difference between the Value added (% of GDP) in Guinea-Bissau and Value added (% of GDP) in Slovak Republic?
Your answer should be very brief. -20.76. In the year 2002, what is the difference between the Value added (% of GDP) in Guinea-Bissau and Value added (% of GDP) in Slovenia?
Provide a short and direct response. -22.22. In the year 2002, what is the difference between the Value added (% of GDP) of Slovak Republic and Value added (% of GDP) of Slovenia?
Offer a very short reply. -1.46. In the year 2003, what is the difference between the Value added (% of GDP) of Fiji and Value added (% of GDP) of Guinea-Bissau?
Your answer should be very brief. 24.22. In the year 2003, what is the difference between the Value added (% of GDP) of Fiji and Value added (% of GDP) of Slovak Republic?
Provide a succinct answer. 2.85. In the year 2003, what is the difference between the Value added (% of GDP) of Fiji and Value added (% of GDP) of Slovenia?
Provide a short and direct response. 0.33. In the year 2003, what is the difference between the Value added (% of GDP) in Guinea-Bissau and Value added (% of GDP) in Slovak Republic?
Provide a short and direct response. -21.37. In the year 2003, what is the difference between the Value added (% of GDP) in Guinea-Bissau and Value added (% of GDP) in Slovenia?
Your response must be concise. -23.89. In the year 2003, what is the difference between the Value added (% of GDP) in Slovak Republic and Value added (% of GDP) in Slovenia?
Keep it short and to the point. -2.52. In the year 2004, what is the difference between the Value added (% of GDP) in Fiji and Value added (% of GDP) in Guinea-Bissau?
Give a very brief answer. 21.61. In the year 2004, what is the difference between the Value added (% of GDP) in Fiji and Value added (% of GDP) in Slovak Republic?
Make the answer very short. 2.52. In the year 2004, what is the difference between the Value added (% of GDP) of Fiji and Value added (% of GDP) of Slovenia?
Provide a short and direct response. -0.54. In the year 2004, what is the difference between the Value added (% of GDP) of Guinea-Bissau and Value added (% of GDP) of Slovak Republic?
Your answer should be compact. -19.09. In the year 2004, what is the difference between the Value added (% of GDP) in Guinea-Bissau and Value added (% of GDP) in Slovenia?
Your answer should be very brief. -22.15. In the year 2004, what is the difference between the Value added (% of GDP) in Slovak Republic and Value added (% of GDP) in Slovenia?
Offer a very short reply. -3.06. What is the ratio of the Value added (% of GDP) in Fiji in 1997 to that in 1998?
Keep it short and to the point. 0.98. What is the ratio of the Value added (% of GDP) in Guinea-Bissau in 1997 to that in 1998?
Provide a short and direct response. 1.21. What is the ratio of the Value added (% of GDP) in Slovak Republic in 1997 to that in 1998?
Provide a succinct answer. 1. What is the ratio of the Value added (% of GDP) of Fiji in 1997 to that in 1999?
Provide a short and direct response. 0.98. What is the ratio of the Value added (% of GDP) of Guinea-Bissau in 1997 to that in 1999?
Offer a terse response. 1.06. What is the ratio of the Value added (% of GDP) of Slovak Republic in 1997 to that in 1999?
Ensure brevity in your answer.  0.98. What is the ratio of the Value added (% of GDP) of Slovenia in 1997 to that in 1999?
Your answer should be very brief. 1. What is the ratio of the Value added (% of GDP) of Fiji in 1997 to that in 2000?
Your response must be concise. 0.95. What is the ratio of the Value added (% of GDP) of Guinea-Bissau in 1997 to that in 2000?
Your answer should be compact. 0.7. What is the ratio of the Value added (% of GDP) in Slovak Republic in 1997 to that in 2000?
Your answer should be compact. 1.01. What is the ratio of the Value added (% of GDP) in Slovenia in 1997 to that in 2000?
Your answer should be compact. 0.98. What is the ratio of the Value added (% of GDP) in Fiji in 1997 to that in 2001?
Give a very brief answer. 0.94. What is the ratio of the Value added (% of GDP) in Guinea-Bissau in 1997 to that in 2001?
Ensure brevity in your answer.  0.64. What is the ratio of the Value added (% of GDP) in Slovenia in 1997 to that in 2001?
Make the answer very short. 0.97. What is the ratio of the Value added (% of GDP) in Fiji in 1997 to that in 2002?
Offer a very short reply. 0.93. What is the ratio of the Value added (% of GDP) of Guinea-Bissau in 1997 to that in 2002?
Your answer should be compact. 0.75. What is the ratio of the Value added (% of GDP) in Slovak Republic in 1997 to that in 2002?
Offer a terse response. 0.99. What is the ratio of the Value added (% of GDP) in Slovenia in 1997 to that in 2002?
Your response must be concise. 0.97. What is the ratio of the Value added (% of GDP) of Fiji in 1997 to that in 2003?
Your answer should be compact. 0.91. What is the ratio of the Value added (% of GDP) in Guinea-Bissau in 1997 to that in 2003?
Offer a terse response. 0.77. What is the ratio of the Value added (% of GDP) of Slovak Republic in 1997 to that in 2003?
Keep it short and to the point. 1. What is the ratio of the Value added (% of GDP) of Slovenia in 1997 to that in 2003?
Make the answer very short. 0.96. What is the ratio of the Value added (% of GDP) in Fiji in 1997 to that in 2004?
Your answer should be very brief. 0.93. What is the ratio of the Value added (% of GDP) of Guinea-Bissau in 1997 to that in 2004?
Provide a short and direct response. 0.74. What is the ratio of the Value added (% of GDP) in Slovak Republic in 1997 to that in 2004?
Give a very brief answer. 1.01. What is the ratio of the Value added (% of GDP) of Slovenia in 1997 to that in 2004?
Provide a short and direct response. 0.96. What is the ratio of the Value added (% of GDP) of Guinea-Bissau in 1998 to that in 1999?
Provide a succinct answer. 0.88. What is the ratio of the Value added (% of GDP) of Slovak Republic in 1998 to that in 1999?
Your response must be concise. 0.98. What is the ratio of the Value added (% of GDP) in Slovenia in 1998 to that in 1999?
Ensure brevity in your answer.  0.99. What is the ratio of the Value added (% of GDP) of Fiji in 1998 to that in 2000?
Your answer should be very brief. 0.97. What is the ratio of the Value added (% of GDP) in Guinea-Bissau in 1998 to that in 2000?
Your response must be concise. 0.58. What is the ratio of the Value added (% of GDP) of Slovak Republic in 1998 to that in 2000?
Ensure brevity in your answer.  1.01. What is the ratio of the Value added (% of GDP) of Slovenia in 1998 to that in 2000?
Offer a very short reply. 0.97. What is the ratio of the Value added (% of GDP) of Fiji in 1998 to that in 2001?
Provide a short and direct response. 0.95. What is the ratio of the Value added (% of GDP) of Guinea-Bissau in 1998 to that in 2001?
Offer a very short reply. 0.53. What is the ratio of the Value added (% of GDP) of Slovak Republic in 1998 to that in 2001?
Ensure brevity in your answer.  1. What is the ratio of the Value added (% of GDP) of Slovenia in 1998 to that in 2001?
Give a very brief answer. 0.97. What is the ratio of the Value added (% of GDP) in Fiji in 1998 to that in 2002?
Keep it short and to the point. 0.95. What is the ratio of the Value added (% of GDP) in Guinea-Bissau in 1998 to that in 2002?
Ensure brevity in your answer.  0.62. What is the ratio of the Value added (% of GDP) in Slovak Republic in 1998 to that in 2002?
Your answer should be compact. 0.99. What is the ratio of the Value added (% of GDP) in Slovenia in 1998 to that in 2002?
Provide a succinct answer. 0.96. What is the ratio of the Value added (% of GDP) in Fiji in 1998 to that in 2003?
Offer a very short reply. 0.93. What is the ratio of the Value added (% of GDP) in Guinea-Bissau in 1998 to that in 2003?
Keep it short and to the point. 0.64. What is the ratio of the Value added (% of GDP) of Slovenia in 1998 to that in 2003?
Your response must be concise. 0.95. What is the ratio of the Value added (% of GDP) in Fiji in 1998 to that in 2004?
Provide a succinct answer. 0.94. What is the ratio of the Value added (% of GDP) of Guinea-Bissau in 1998 to that in 2004?
Provide a short and direct response. 0.61. What is the ratio of the Value added (% of GDP) of Slovenia in 1998 to that in 2004?
Offer a very short reply. 0.96. What is the ratio of the Value added (% of GDP) of Fiji in 1999 to that in 2000?
Your response must be concise. 0.97. What is the ratio of the Value added (% of GDP) in Guinea-Bissau in 1999 to that in 2000?
Ensure brevity in your answer.  0.66. What is the ratio of the Value added (% of GDP) in Slovak Republic in 1999 to that in 2000?
Offer a terse response. 1.03. What is the ratio of the Value added (% of GDP) in Slovenia in 1999 to that in 2000?
Provide a short and direct response. 0.98. What is the ratio of the Value added (% of GDP) in Fiji in 1999 to that in 2001?
Your answer should be very brief. 0.95. What is the ratio of the Value added (% of GDP) in Guinea-Bissau in 1999 to that in 2001?
Keep it short and to the point. 0.6. What is the ratio of the Value added (% of GDP) of Slovak Republic in 1999 to that in 2001?
Keep it short and to the point. 1.02. What is the ratio of the Value added (% of GDP) in Slovenia in 1999 to that in 2001?
Provide a succinct answer. 0.98. What is the ratio of the Value added (% of GDP) in Fiji in 1999 to that in 2002?
Offer a very short reply. 0.95. What is the ratio of the Value added (% of GDP) of Guinea-Bissau in 1999 to that in 2002?
Provide a succinct answer. 0.71. What is the ratio of the Value added (% of GDP) in Slovak Republic in 1999 to that in 2002?
Offer a very short reply. 1.01. What is the ratio of the Value added (% of GDP) of Fiji in 1999 to that in 2003?
Provide a succinct answer. 0.93. What is the ratio of the Value added (% of GDP) in Guinea-Bissau in 1999 to that in 2003?
Give a very brief answer. 0.73. What is the ratio of the Value added (% of GDP) in Slovak Republic in 1999 to that in 2003?
Your answer should be very brief. 1.02. What is the ratio of the Value added (% of GDP) of Slovenia in 1999 to that in 2003?
Provide a succinct answer. 0.96. What is the ratio of the Value added (% of GDP) of Fiji in 1999 to that in 2004?
Keep it short and to the point. 0.95. What is the ratio of the Value added (% of GDP) in Guinea-Bissau in 1999 to that in 2004?
Provide a succinct answer. 0.7. What is the ratio of the Value added (% of GDP) of Slovak Republic in 1999 to that in 2004?
Your answer should be very brief. 1.03. What is the ratio of the Value added (% of GDP) in Slovenia in 1999 to that in 2004?
Your answer should be very brief. 0.97. What is the ratio of the Value added (% of GDP) of Fiji in 2000 to that in 2001?
Your answer should be very brief. 0.98. What is the ratio of the Value added (% of GDP) in Slovenia in 2000 to that in 2001?
Keep it short and to the point. 0.99. What is the ratio of the Value added (% of GDP) of Fiji in 2000 to that in 2002?
Keep it short and to the point. 0.98. What is the ratio of the Value added (% of GDP) in Guinea-Bissau in 2000 to that in 2002?
Your response must be concise. 1.07. What is the ratio of the Value added (% of GDP) in Slovak Republic in 2000 to that in 2002?
Your answer should be very brief. 0.98. What is the ratio of the Value added (% of GDP) in Slovenia in 2000 to that in 2002?
Keep it short and to the point. 0.99. What is the ratio of the Value added (% of GDP) in Fiji in 2000 to that in 2003?
Give a very brief answer. 0.96. What is the ratio of the Value added (% of GDP) in Guinea-Bissau in 2000 to that in 2003?
Provide a short and direct response. 1.1. What is the ratio of the Value added (% of GDP) of Slovak Republic in 2000 to that in 2003?
Provide a short and direct response. 0.99. What is the ratio of the Value added (% of GDP) of Slovenia in 2000 to that in 2003?
Keep it short and to the point. 0.98. What is the ratio of the Value added (% of GDP) in Fiji in 2000 to that in 2004?
Provide a short and direct response. 0.97. What is the ratio of the Value added (% of GDP) of Guinea-Bissau in 2000 to that in 2004?
Offer a terse response. 1.05. What is the ratio of the Value added (% of GDP) of Slovenia in 2000 to that in 2004?
Your answer should be compact. 0.98. What is the ratio of the Value added (% of GDP) in Fiji in 2001 to that in 2002?
Offer a very short reply. 1. What is the ratio of the Value added (% of GDP) of Guinea-Bissau in 2001 to that in 2002?
Your answer should be compact. 1.17. What is the ratio of the Value added (% of GDP) of Slovak Republic in 2001 to that in 2002?
Your response must be concise. 0.99. What is the ratio of the Value added (% of GDP) in Fiji in 2001 to that in 2003?
Provide a short and direct response. 0.97. What is the ratio of the Value added (% of GDP) in Guinea-Bissau in 2001 to that in 2003?
Offer a terse response. 1.21. What is the ratio of the Value added (% of GDP) of Slovak Republic in 2001 to that in 2003?
Keep it short and to the point. 1. What is the ratio of the Value added (% of GDP) in Slovenia in 2001 to that in 2003?
Offer a terse response. 0.99. What is the ratio of the Value added (% of GDP) in Guinea-Bissau in 2001 to that in 2004?
Your answer should be compact. 1.16. What is the ratio of the Value added (% of GDP) in Slovak Republic in 2001 to that in 2004?
Ensure brevity in your answer.  1.01. What is the ratio of the Value added (% of GDP) in Slovenia in 2001 to that in 2004?
Ensure brevity in your answer.  0.99. What is the ratio of the Value added (% of GDP) of Fiji in 2002 to that in 2003?
Keep it short and to the point. 0.98. What is the ratio of the Value added (% of GDP) of Guinea-Bissau in 2002 to that in 2003?
Offer a very short reply. 1.03. What is the ratio of the Value added (% of GDP) in Slovak Republic in 2002 to that in 2003?
Provide a short and direct response. 1.01. What is the ratio of the Value added (% of GDP) in Slovenia in 2002 to that in 2003?
Provide a short and direct response. 0.99. What is the ratio of the Value added (% of GDP) of Guinea-Bissau in 2002 to that in 2004?
Provide a short and direct response. 0.99. What is the ratio of the Value added (% of GDP) of Slovak Republic in 2002 to that in 2004?
Offer a terse response. 1.02. What is the ratio of the Value added (% of GDP) of Slovenia in 2002 to that in 2004?
Provide a short and direct response. 0.99. What is the ratio of the Value added (% of GDP) of Fiji in 2003 to that in 2004?
Your answer should be very brief. 1.02. What is the ratio of the Value added (% of GDP) in Guinea-Bissau in 2003 to that in 2004?
Provide a succinct answer. 0.96. What is the ratio of the Value added (% of GDP) in Slovak Republic in 2003 to that in 2004?
Your response must be concise. 1.01. What is the ratio of the Value added (% of GDP) of Slovenia in 2003 to that in 2004?
Your response must be concise. 1. What is the difference between the highest and the second highest Value added (% of GDP) of Fiji?
Offer a terse response. 1. What is the difference between the highest and the second highest Value added (% of GDP) of Guinea-Bissau?
Provide a succinct answer. 4.28. What is the difference between the highest and the second highest Value added (% of GDP) of Slovak Republic?
Your answer should be compact. 0.52. What is the difference between the highest and the second highest Value added (% of GDP) of Slovenia?
Offer a terse response. 0.13. What is the difference between the highest and the lowest Value added (% of GDP) in Fiji?
Keep it short and to the point. 5.54. What is the difference between the highest and the lowest Value added (% of GDP) in Guinea-Bissau?
Your response must be concise. 22.15. What is the difference between the highest and the lowest Value added (% of GDP) of Slovak Republic?
Give a very brief answer. 1.87. What is the difference between the highest and the lowest Value added (% of GDP) of Slovenia?
Make the answer very short. 2.88. 